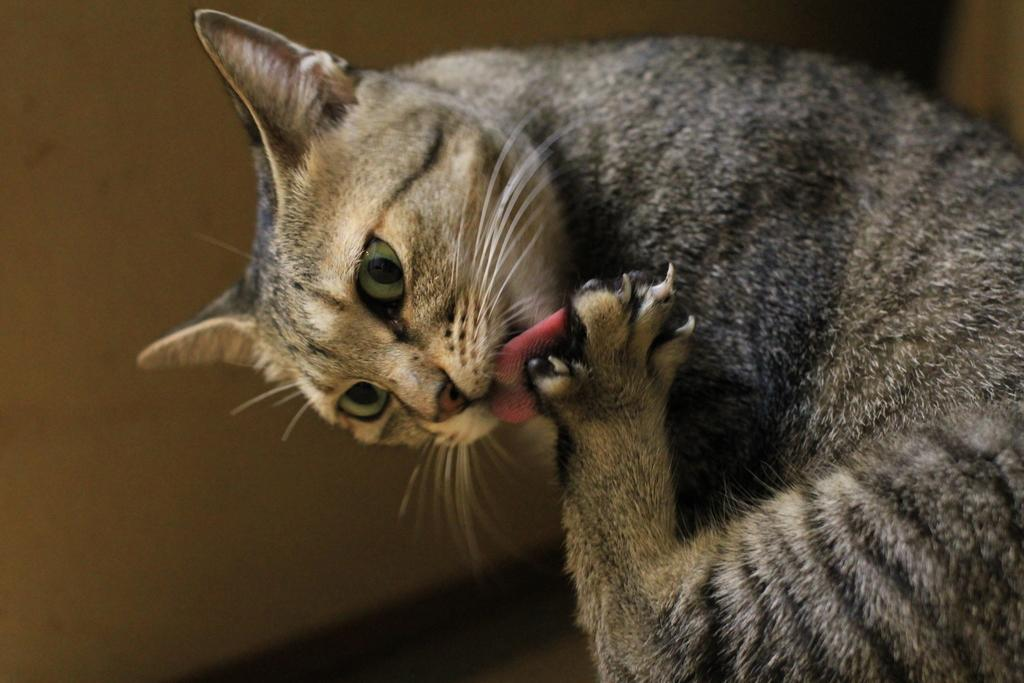What type of animal is in the image? There is a cat in the image. What is the cat doing in the image? The cat is holding an object. Who is the guide in the image? There is no guide present in the image; it features a cat holding an object. What type of milk is being served in the image? There is no milk present in the image; it features a cat holding an object. 